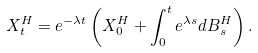<formula> <loc_0><loc_0><loc_500><loc_500>X _ { t } ^ { H } = e ^ { - \lambda t } \left ( X ^ { H } _ { 0 } + \int _ { 0 } ^ { t } e ^ { \lambda s } d B _ { s } ^ { H } \right ) .</formula> 